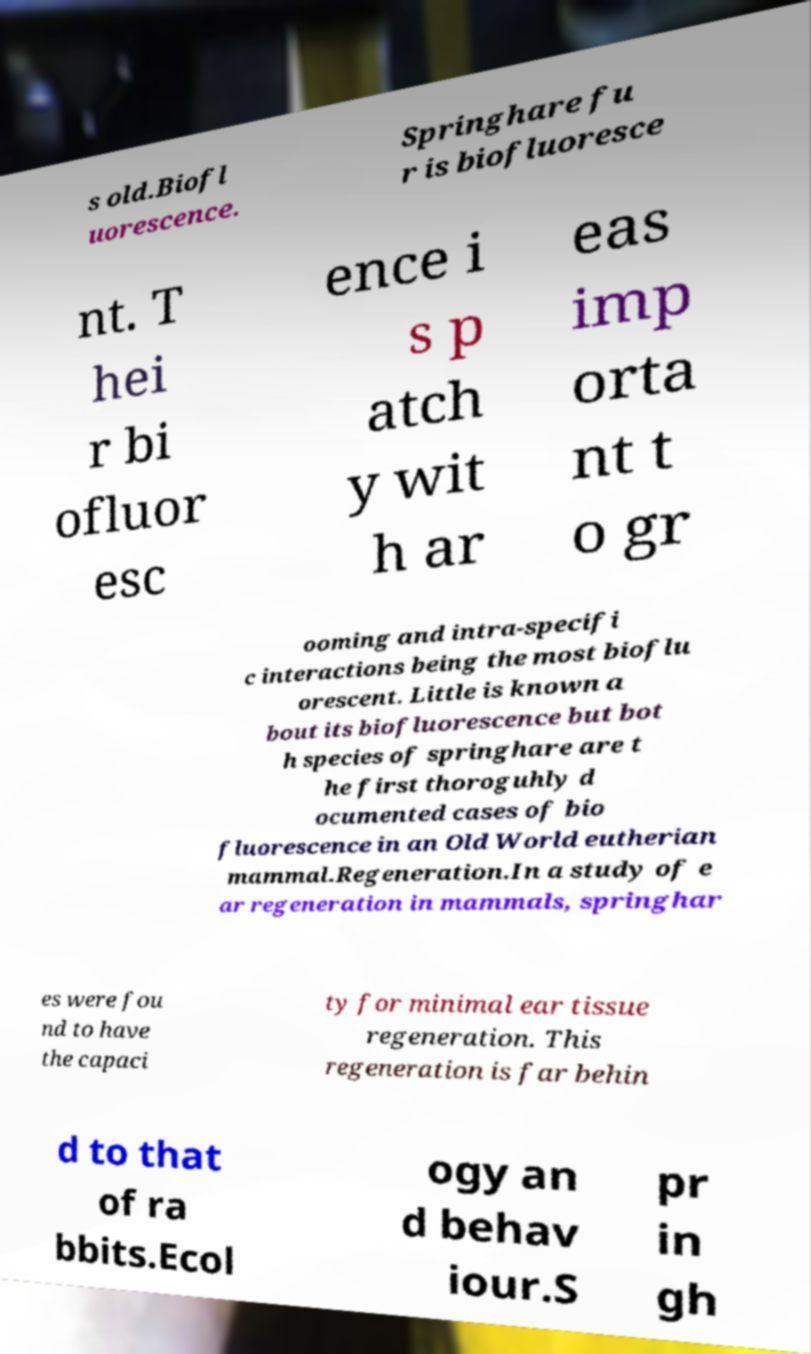Could you assist in decoding the text presented in this image and type it out clearly? s old.Biofl uorescence. Springhare fu r is biofluoresce nt. T hei r bi ofluor esc ence i s p atch y wit h ar eas imp orta nt t o gr ooming and intra-specifi c interactions being the most bioflu orescent. Little is known a bout its biofluorescence but bot h species of springhare are t he first thoroguhly d ocumented cases of bio fluorescence in an Old World eutherian mammal.Regeneration.In a study of e ar regeneration in mammals, springhar es were fou nd to have the capaci ty for minimal ear tissue regeneration. This regeneration is far behin d to that of ra bbits.Ecol ogy an d behav iour.S pr in gh 